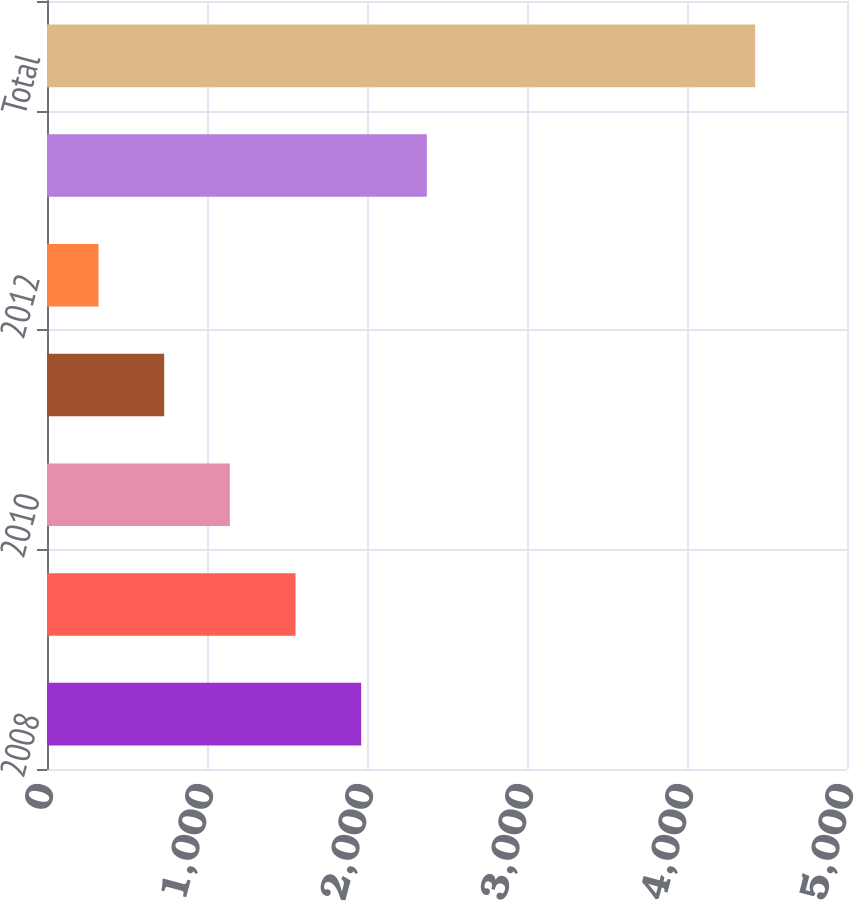Convert chart to OTSL. <chart><loc_0><loc_0><loc_500><loc_500><bar_chart><fcel>2008<fcel>2009<fcel>2010<fcel>2011<fcel>2012<fcel>Remaining years after 2012<fcel>Total<nl><fcel>1963.6<fcel>1553.2<fcel>1142.8<fcel>732.4<fcel>322<fcel>2374<fcel>4426<nl></chart> 